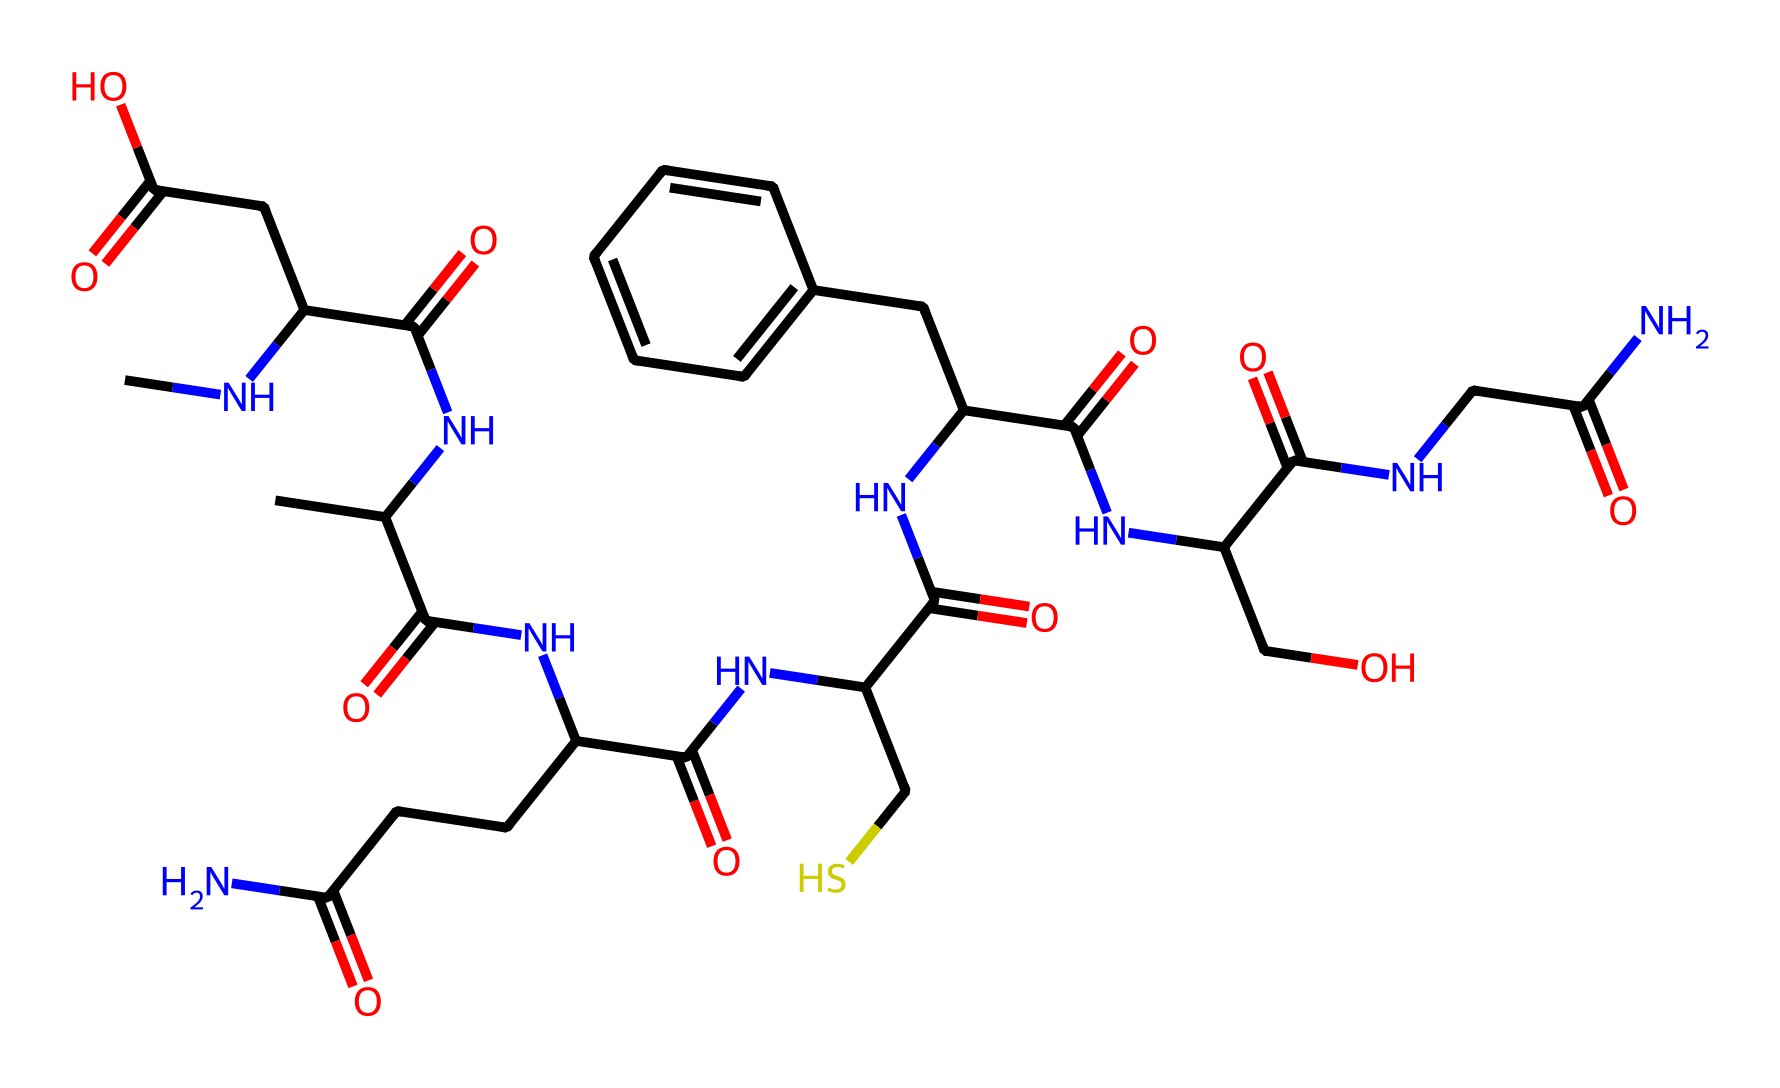what is the main functional group present in this polymer? The polymer structure contains multiple carbonyl (C=O) groups found in amides as evident from the multiple NC(=O) linkages throughout the structure.
Answer: carbonyl how many nitrogen atoms are in this chemical structure? By analyzing the structure, there are several amide groups indicated by the "N" presence along with carbonyls, totaling six nitrogen atoms present in the entire polymer.
Answer: six what is the effect of the carbonyl functional groups on the polymer's properties? Carbonyl groups contribute to hydrogen bonding and polarity, which can enhance the film's moisture resistance and mechanical strength through intermolecular forces, making the film more durable and stable.
Answer: enhanced durability how many distinct repeating units are observed in this polymer structure? The chain displays distinct amide groups interlinked, indicating a repetitive structure; as evidenced, there are five noticeable repeating amide segments in the polymer backbone.
Answer: five what type of polymerization process is likely used to form this structure? Given the presence of multiple amide bonds and functional groups, this polymer would likely have formed through step-growth polymerization, where the monomers react to form long chains with amides as a linking feature.
Answer: step-growth polymerization 